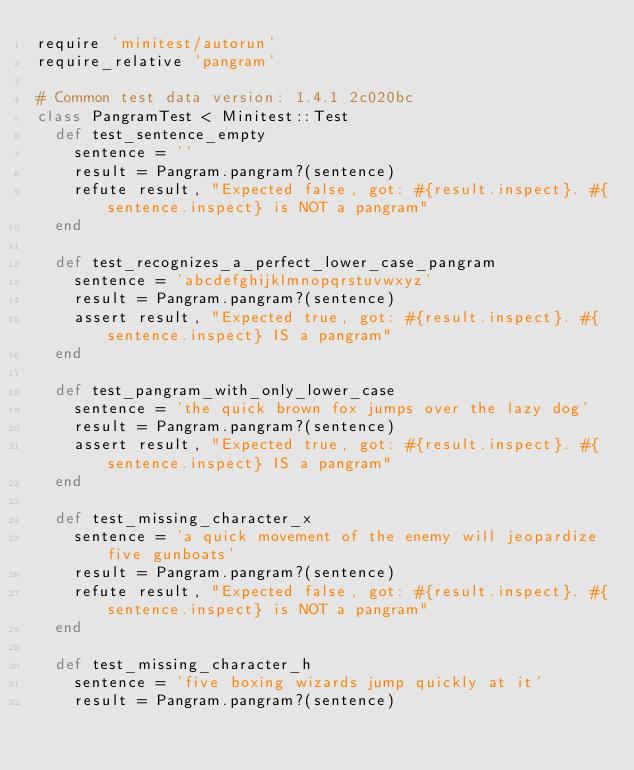<code> <loc_0><loc_0><loc_500><loc_500><_Ruby_>require 'minitest/autorun'
require_relative 'pangram'

# Common test data version: 1.4.1 2c020bc
class PangramTest < Minitest::Test
  def test_sentence_empty
    sentence = ''
    result = Pangram.pangram?(sentence)
    refute result, "Expected false, got: #{result.inspect}. #{sentence.inspect} is NOT a pangram"
  end

  def test_recognizes_a_perfect_lower_case_pangram
    sentence = 'abcdefghijklmnopqrstuvwxyz'
    result = Pangram.pangram?(sentence)
    assert result, "Expected true, got: #{result.inspect}. #{sentence.inspect} IS a pangram"
  end

  def test_pangram_with_only_lower_case
    sentence = 'the quick brown fox jumps over the lazy dog'
    result = Pangram.pangram?(sentence)
    assert result, "Expected true, got: #{result.inspect}. #{sentence.inspect} IS a pangram"
  end

  def test_missing_character_x
    sentence = 'a quick movement of the enemy will jeopardize five gunboats'
    result = Pangram.pangram?(sentence)
    refute result, "Expected false, got: #{result.inspect}. #{sentence.inspect} is NOT a pangram"
  end

  def test_missing_character_h
    sentence = 'five boxing wizards jump quickly at it'
    result = Pangram.pangram?(sentence)</code> 